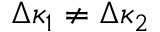<formula> <loc_0><loc_0><loc_500><loc_500>\Delta \kappa _ { 1 } \neq \Delta \kappa _ { 2 }</formula> 